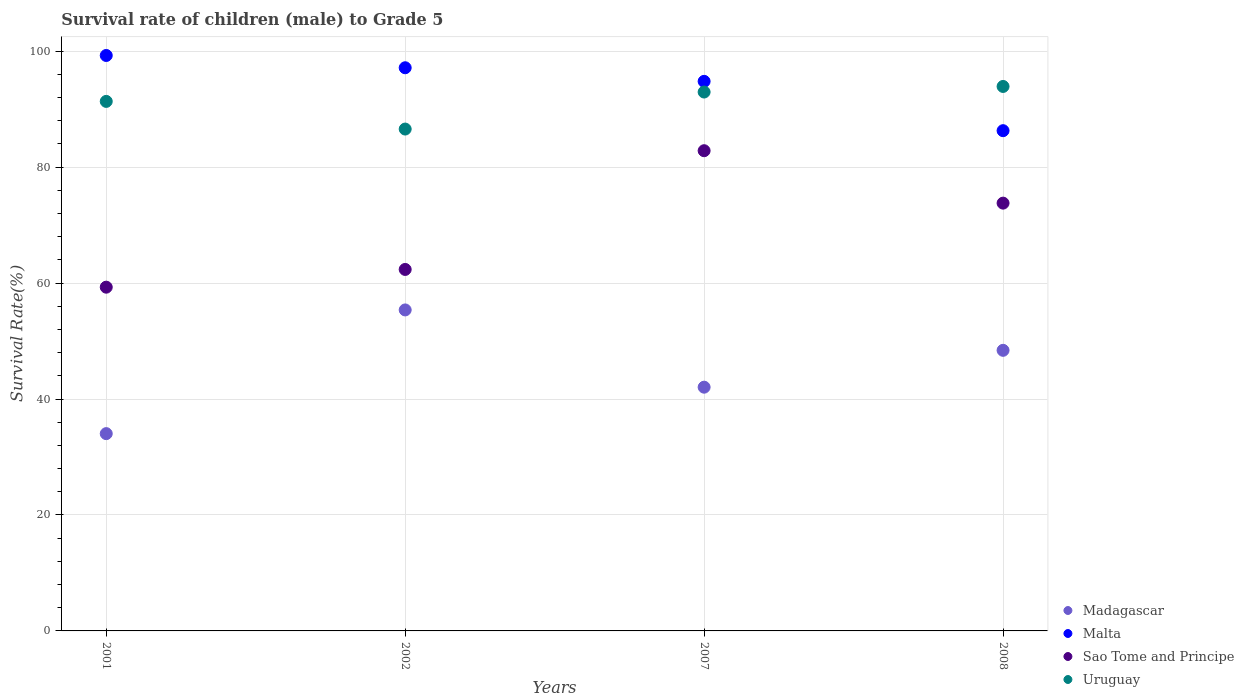Is the number of dotlines equal to the number of legend labels?
Your response must be concise. Yes. What is the survival rate of male children to grade 5 in Madagascar in 2008?
Make the answer very short. 48.4. Across all years, what is the maximum survival rate of male children to grade 5 in Madagascar?
Give a very brief answer. 55.37. Across all years, what is the minimum survival rate of male children to grade 5 in Malta?
Provide a short and direct response. 86.29. What is the total survival rate of male children to grade 5 in Sao Tome and Principe in the graph?
Provide a succinct answer. 278.27. What is the difference between the survival rate of male children to grade 5 in Uruguay in 2002 and that in 2008?
Make the answer very short. -7.35. What is the difference between the survival rate of male children to grade 5 in Uruguay in 2001 and the survival rate of male children to grade 5 in Malta in 2007?
Provide a succinct answer. -3.46. What is the average survival rate of male children to grade 5 in Madagascar per year?
Offer a terse response. 44.96. In the year 2008, what is the difference between the survival rate of male children to grade 5 in Sao Tome and Principe and survival rate of male children to grade 5 in Madagascar?
Make the answer very short. 25.39. What is the ratio of the survival rate of male children to grade 5 in Madagascar in 2002 to that in 2008?
Ensure brevity in your answer.  1.14. Is the survival rate of male children to grade 5 in Sao Tome and Principe in 2001 less than that in 2002?
Offer a very short reply. Yes. Is the difference between the survival rate of male children to grade 5 in Sao Tome and Principe in 2007 and 2008 greater than the difference between the survival rate of male children to grade 5 in Madagascar in 2007 and 2008?
Provide a succinct answer. Yes. What is the difference between the highest and the second highest survival rate of male children to grade 5 in Madagascar?
Ensure brevity in your answer.  6.97. What is the difference between the highest and the lowest survival rate of male children to grade 5 in Sao Tome and Principe?
Your answer should be very brief. 23.54. In how many years, is the survival rate of male children to grade 5 in Uruguay greater than the average survival rate of male children to grade 5 in Uruguay taken over all years?
Keep it short and to the point. 3. Is it the case that in every year, the sum of the survival rate of male children to grade 5 in Madagascar and survival rate of male children to grade 5 in Uruguay  is greater than the survival rate of male children to grade 5 in Sao Tome and Principe?
Keep it short and to the point. Yes. Does the survival rate of male children to grade 5 in Malta monotonically increase over the years?
Provide a short and direct response. No. How many dotlines are there?
Your answer should be very brief. 4. Does the graph contain grids?
Keep it short and to the point. Yes. What is the title of the graph?
Provide a succinct answer. Survival rate of children (male) to Grade 5. Does "OECD members" appear as one of the legend labels in the graph?
Make the answer very short. No. What is the label or title of the X-axis?
Offer a terse response. Years. What is the label or title of the Y-axis?
Ensure brevity in your answer.  Survival Rate(%). What is the Survival Rate(%) of Madagascar in 2001?
Provide a short and direct response. 34.03. What is the Survival Rate(%) in Malta in 2001?
Provide a short and direct response. 99.26. What is the Survival Rate(%) of Sao Tome and Principe in 2001?
Offer a terse response. 59.29. What is the Survival Rate(%) of Uruguay in 2001?
Make the answer very short. 91.34. What is the Survival Rate(%) of Madagascar in 2002?
Your answer should be very brief. 55.37. What is the Survival Rate(%) in Malta in 2002?
Your response must be concise. 97.14. What is the Survival Rate(%) in Sao Tome and Principe in 2002?
Keep it short and to the point. 62.35. What is the Survival Rate(%) in Uruguay in 2002?
Keep it short and to the point. 86.57. What is the Survival Rate(%) in Madagascar in 2007?
Keep it short and to the point. 42.04. What is the Survival Rate(%) of Malta in 2007?
Provide a short and direct response. 94.8. What is the Survival Rate(%) of Sao Tome and Principe in 2007?
Keep it short and to the point. 82.83. What is the Survival Rate(%) of Uruguay in 2007?
Your response must be concise. 92.95. What is the Survival Rate(%) of Madagascar in 2008?
Your response must be concise. 48.4. What is the Survival Rate(%) of Malta in 2008?
Offer a very short reply. 86.29. What is the Survival Rate(%) of Sao Tome and Principe in 2008?
Your answer should be very brief. 73.79. What is the Survival Rate(%) of Uruguay in 2008?
Your answer should be very brief. 93.92. Across all years, what is the maximum Survival Rate(%) of Madagascar?
Provide a short and direct response. 55.37. Across all years, what is the maximum Survival Rate(%) in Malta?
Keep it short and to the point. 99.26. Across all years, what is the maximum Survival Rate(%) in Sao Tome and Principe?
Your answer should be very brief. 82.83. Across all years, what is the maximum Survival Rate(%) of Uruguay?
Give a very brief answer. 93.92. Across all years, what is the minimum Survival Rate(%) of Madagascar?
Provide a short and direct response. 34.03. Across all years, what is the minimum Survival Rate(%) of Malta?
Your answer should be very brief. 86.29. Across all years, what is the minimum Survival Rate(%) of Sao Tome and Principe?
Provide a succinct answer. 59.29. Across all years, what is the minimum Survival Rate(%) in Uruguay?
Make the answer very short. 86.57. What is the total Survival Rate(%) in Madagascar in the graph?
Provide a succinct answer. 179.84. What is the total Survival Rate(%) in Malta in the graph?
Provide a succinct answer. 377.48. What is the total Survival Rate(%) of Sao Tome and Principe in the graph?
Make the answer very short. 278.27. What is the total Survival Rate(%) of Uruguay in the graph?
Offer a terse response. 364.77. What is the difference between the Survival Rate(%) of Madagascar in 2001 and that in 2002?
Offer a very short reply. -21.34. What is the difference between the Survival Rate(%) in Malta in 2001 and that in 2002?
Give a very brief answer. 2.12. What is the difference between the Survival Rate(%) of Sao Tome and Principe in 2001 and that in 2002?
Your response must be concise. -3.06. What is the difference between the Survival Rate(%) of Uruguay in 2001 and that in 2002?
Your answer should be compact. 4.77. What is the difference between the Survival Rate(%) in Madagascar in 2001 and that in 2007?
Your answer should be compact. -8.01. What is the difference between the Survival Rate(%) of Malta in 2001 and that in 2007?
Offer a very short reply. 4.46. What is the difference between the Survival Rate(%) of Sao Tome and Principe in 2001 and that in 2007?
Make the answer very short. -23.54. What is the difference between the Survival Rate(%) of Uruguay in 2001 and that in 2007?
Offer a terse response. -1.61. What is the difference between the Survival Rate(%) in Madagascar in 2001 and that in 2008?
Offer a terse response. -14.37. What is the difference between the Survival Rate(%) in Malta in 2001 and that in 2008?
Your response must be concise. 12.97. What is the difference between the Survival Rate(%) of Sao Tome and Principe in 2001 and that in 2008?
Give a very brief answer. -14.5. What is the difference between the Survival Rate(%) in Uruguay in 2001 and that in 2008?
Make the answer very short. -2.58. What is the difference between the Survival Rate(%) in Madagascar in 2002 and that in 2007?
Make the answer very short. 13.32. What is the difference between the Survival Rate(%) of Malta in 2002 and that in 2007?
Provide a succinct answer. 2.35. What is the difference between the Survival Rate(%) of Sao Tome and Principe in 2002 and that in 2007?
Offer a very short reply. -20.48. What is the difference between the Survival Rate(%) in Uruguay in 2002 and that in 2007?
Offer a terse response. -6.39. What is the difference between the Survival Rate(%) of Madagascar in 2002 and that in 2008?
Ensure brevity in your answer.  6.97. What is the difference between the Survival Rate(%) of Malta in 2002 and that in 2008?
Offer a terse response. 10.85. What is the difference between the Survival Rate(%) in Sao Tome and Principe in 2002 and that in 2008?
Provide a succinct answer. -11.44. What is the difference between the Survival Rate(%) of Uruguay in 2002 and that in 2008?
Give a very brief answer. -7.35. What is the difference between the Survival Rate(%) of Madagascar in 2007 and that in 2008?
Your response must be concise. -6.36. What is the difference between the Survival Rate(%) of Malta in 2007 and that in 2008?
Give a very brief answer. 8.51. What is the difference between the Survival Rate(%) of Sao Tome and Principe in 2007 and that in 2008?
Make the answer very short. 9.04. What is the difference between the Survival Rate(%) of Uruguay in 2007 and that in 2008?
Provide a succinct answer. -0.96. What is the difference between the Survival Rate(%) in Madagascar in 2001 and the Survival Rate(%) in Malta in 2002?
Make the answer very short. -63.11. What is the difference between the Survival Rate(%) of Madagascar in 2001 and the Survival Rate(%) of Sao Tome and Principe in 2002?
Keep it short and to the point. -28.32. What is the difference between the Survival Rate(%) in Madagascar in 2001 and the Survival Rate(%) in Uruguay in 2002?
Offer a terse response. -52.54. What is the difference between the Survival Rate(%) in Malta in 2001 and the Survival Rate(%) in Sao Tome and Principe in 2002?
Provide a short and direct response. 36.91. What is the difference between the Survival Rate(%) in Malta in 2001 and the Survival Rate(%) in Uruguay in 2002?
Provide a succinct answer. 12.69. What is the difference between the Survival Rate(%) in Sao Tome and Principe in 2001 and the Survival Rate(%) in Uruguay in 2002?
Make the answer very short. -27.27. What is the difference between the Survival Rate(%) in Madagascar in 2001 and the Survival Rate(%) in Malta in 2007?
Provide a short and direct response. -60.77. What is the difference between the Survival Rate(%) in Madagascar in 2001 and the Survival Rate(%) in Sao Tome and Principe in 2007?
Ensure brevity in your answer.  -48.8. What is the difference between the Survival Rate(%) in Madagascar in 2001 and the Survival Rate(%) in Uruguay in 2007?
Make the answer very short. -58.92. What is the difference between the Survival Rate(%) in Malta in 2001 and the Survival Rate(%) in Sao Tome and Principe in 2007?
Make the answer very short. 16.43. What is the difference between the Survival Rate(%) of Malta in 2001 and the Survival Rate(%) of Uruguay in 2007?
Make the answer very short. 6.31. What is the difference between the Survival Rate(%) in Sao Tome and Principe in 2001 and the Survival Rate(%) in Uruguay in 2007?
Your response must be concise. -33.66. What is the difference between the Survival Rate(%) of Madagascar in 2001 and the Survival Rate(%) of Malta in 2008?
Keep it short and to the point. -52.26. What is the difference between the Survival Rate(%) of Madagascar in 2001 and the Survival Rate(%) of Sao Tome and Principe in 2008?
Your answer should be very brief. -39.76. What is the difference between the Survival Rate(%) in Madagascar in 2001 and the Survival Rate(%) in Uruguay in 2008?
Keep it short and to the point. -59.88. What is the difference between the Survival Rate(%) in Malta in 2001 and the Survival Rate(%) in Sao Tome and Principe in 2008?
Provide a succinct answer. 25.47. What is the difference between the Survival Rate(%) of Malta in 2001 and the Survival Rate(%) of Uruguay in 2008?
Your response must be concise. 5.34. What is the difference between the Survival Rate(%) in Sao Tome and Principe in 2001 and the Survival Rate(%) in Uruguay in 2008?
Your response must be concise. -34.62. What is the difference between the Survival Rate(%) in Madagascar in 2002 and the Survival Rate(%) in Malta in 2007?
Give a very brief answer. -39.43. What is the difference between the Survival Rate(%) of Madagascar in 2002 and the Survival Rate(%) of Sao Tome and Principe in 2007?
Your answer should be compact. -27.46. What is the difference between the Survival Rate(%) of Madagascar in 2002 and the Survival Rate(%) of Uruguay in 2007?
Your answer should be compact. -37.59. What is the difference between the Survival Rate(%) in Malta in 2002 and the Survival Rate(%) in Sao Tome and Principe in 2007?
Provide a succinct answer. 14.31. What is the difference between the Survival Rate(%) of Malta in 2002 and the Survival Rate(%) of Uruguay in 2007?
Your response must be concise. 4.19. What is the difference between the Survival Rate(%) in Sao Tome and Principe in 2002 and the Survival Rate(%) in Uruguay in 2007?
Your answer should be compact. -30.6. What is the difference between the Survival Rate(%) of Madagascar in 2002 and the Survival Rate(%) of Malta in 2008?
Your response must be concise. -30.92. What is the difference between the Survival Rate(%) of Madagascar in 2002 and the Survival Rate(%) of Sao Tome and Principe in 2008?
Offer a terse response. -18.42. What is the difference between the Survival Rate(%) of Madagascar in 2002 and the Survival Rate(%) of Uruguay in 2008?
Offer a very short reply. -38.55. What is the difference between the Survival Rate(%) in Malta in 2002 and the Survival Rate(%) in Sao Tome and Principe in 2008?
Ensure brevity in your answer.  23.35. What is the difference between the Survival Rate(%) in Malta in 2002 and the Survival Rate(%) in Uruguay in 2008?
Your answer should be very brief. 3.23. What is the difference between the Survival Rate(%) in Sao Tome and Principe in 2002 and the Survival Rate(%) in Uruguay in 2008?
Offer a terse response. -31.56. What is the difference between the Survival Rate(%) of Madagascar in 2007 and the Survival Rate(%) of Malta in 2008?
Give a very brief answer. -44.24. What is the difference between the Survival Rate(%) in Madagascar in 2007 and the Survival Rate(%) in Sao Tome and Principe in 2008?
Make the answer very short. -31.75. What is the difference between the Survival Rate(%) in Madagascar in 2007 and the Survival Rate(%) in Uruguay in 2008?
Offer a very short reply. -51.87. What is the difference between the Survival Rate(%) in Malta in 2007 and the Survival Rate(%) in Sao Tome and Principe in 2008?
Offer a very short reply. 21.01. What is the difference between the Survival Rate(%) in Malta in 2007 and the Survival Rate(%) in Uruguay in 2008?
Your answer should be very brief. 0.88. What is the difference between the Survival Rate(%) in Sao Tome and Principe in 2007 and the Survival Rate(%) in Uruguay in 2008?
Provide a short and direct response. -11.08. What is the average Survival Rate(%) in Madagascar per year?
Your response must be concise. 44.96. What is the average Survival Rate(%) of Malta per year?
Your response must be concise. 94.37. What is the average Survival Rate(%) in Sao Tome and Principe per year?
Offer a terse response. 69.57. What is the average Survival Rate(%) in Uruguay per year?
Make the answer very short. 91.19. In the year 2001, what is the difference between the Survival Rate(%) in Madagascar and Survival Rate(%) in Malta?
Ensure brevity in your answer.  -65.23. In the year 2001, what is the difference between the Survival Rate(%) in Madagascar and Survival Rate(%) in Sao Tome and Principe?
Your answer should be very brief. -25.26. In the year 2001, what is the difference between the Survival Rate(%) in Madagascar and Survival Rate(%) in Uruguay?
Provide a succinct answer. -57.31. In the year 2001, what is the difference between the Survival Rate(%) in Malta and Survival Rate(%) in Sao Tome and Principe?
Your answer should be compact. 39.97. In the year 2001, what is the difference between the Survival Rate(%) of Malta and Survival Rate(%) of Uruguay?
Your answer should be compact. 7.92. In the year 2001, what is the difference between the Survival Rate(%) of Sao Tome and Principe and Survival Rate(%) of Uruguay?
Offer a very short reply. -32.05. In the year 2002, what is the difference between the Survival Rate(%) of Madagascar and Survival Rate(%) of Malta?
Offer a very short reply. -41.77. In the year 2002, what is the difference between the Survival Rate(%) of Madagascar and Survival Rate(%) of Sao Tome and Principe?
Provide a short and direct response. -6.98. In the year 2002, what is the difference between the Survival Rate(%) in Madagascar and Survival Rate(%) in Uruguay?
Keep it short and to the point. -31.2. In the year 2002, what is the difference between the Survival Rate(%) of Malta and Survival Rate(%) of Sao Tome and Principe?
Your response must be concise. 34.79. In the year 2002, what is the difference between the Survival Rate(%) of Malta and Survival Rate(%) of Uruguay?
Your response must be concise. 10.58. In the year 2002, what is the difference between the Survival Rate(%) of Sao Tome and Principe and Survival Rate(%) of Uruguay?
Give a very brief answer. -24.21. In the year 2007, what is the difference between the Survival Rate(%) of Madagascar and Survival Rate(%) of Malta?
Offer a very short reply. -52.75. In the year 2007, what is the difference between the Survival Rate(%) of Madagascar and Survival Rate(%) of Sao Tome and Principe?
Ensure brevity in your answer.  -40.79. In the year 2007, what is the difference between the Survival Rate(%) in Madagascar and Survival Rate(%) in Uruguay?
Provide a short and direct response. -50.91. In the year 2007, what is the difference between the Survival Rate(%) in Malta and Survival Rate(%) in Sao Tome and Principe?
Your answer should be very brief. 11.96. In the year 2007, what is the difference between the Survival Rate(%) in Malta and Survival Rate(%) in Uruguay?
Keep it short and to the point. 1.84. In the year 2007, what is the difference between the Survival Rate(%) in Sao Tome and Principe and Survival Rate(%) in Uruguay?
Ensure brevity in your answer.  -10.12. In the year 2008, what is the difference between the Survival Rate(%) of Madagascar and Survival Rate(%) of Malta?
Offer a very short reply. -37.89. In the year 2008, what is the difference between the Survival Rate(%) in Madagascar and Survival Rate(%) in Sao Tome and Principe?
Keep it short and to the point. -25.39. In the year 2008, what is the difference between the Survival Rate(%) in Madagascar and Survival Rate(%) in Uruguay?
Keep it short and to the point. -45.52. In the year 2008, what is the difference between the Survival Rate(%) in Malta and Survival Rate(%) in Sao Tome and Principe?
Make the answer very short. 12.5. In the year 2008, what is the difference between the Survival Rate(%) of Malta and Survival Rate(%) of Uruguay?
Your answer should be very brief. -7.63. In the year 2008, what is the difference between the Survival Rate(%) of Sao Tome and Principe and Survival Rate(%) of Uruguay?
Offer a very short reply. -20.13. What is the ratio of the Survival Rate(%) of Madagascar in 2001 to that in 2002?
Offer a terse response. 0.61. What is the ratio of the Survival Rate(%) of Malta in 2001 to that in 2002?
Your response must be concise. 1.02. What is the ratio of the Survival Rate(%) of Sao Tome and Principe in 2001 to that in 2002?
Offer a terse response. 0.95. What is the ratio of the Survival Rate(%) of Uruguay in 2001 to that in 2002?
Keep it short and to the point. 1.06. What is the ratio of the Survival Rate(%) of Madagascar in 2001 to that in 2007?
Make the answer very short. 0.81. What is the ratio of the Survival Rate(%) in Malta in 2001 to that in 2007?
Keep it short and to the point. 1.05. What is the ratio of the Survival Rate(%) in Sao Tome and Principe in 2001 to that in 2007?
Keep it short and to the point. 0.72. What is the ratio of the Survival Rate(%) of Uruguay in 2001 to that in 2007?
Make the answer very short. 0.98. What is the ratio of the Survival Rate(%) of Madagascar in 2001 to that in 2008?
Offer a terse response. 0.7. What is the ratio of the Survival Rate(%) of Malta in 2001 to that in 2008?
Give a very brief answer. 1.15. What is the ratio of the Survival Rate(%) in Sao Tome and Principe in 2001 to that in 2008?
Your answer should be compact. 0.8. What is the ratio of the Survival Rate(%) of Uruguay in 2001 to that in 2008?
Offer a very short reply. 0.97. What is the ratio of the Survival Rate(%) of Madagascar in 2002 to that in 2007?
Ensure brevity in your answer.  1.32. What is the ratio of the Survival Rate(%) in Malta in 2002 to that in 2007?
Provide a succinct answer. 1.02. What is the ratio of the Survival Rate(%) in Sao Tome and Principe in 2002 to that in 2007?
Provide a succinct answer. 0.75. What is the ratio of the Survival Rate(%) in Uruguay in 2002 to that in 2007?
Give a very brief answer. 0.93. What is the ratio of the Survival Rate(%) of Madagascar in 2002 to that in 2008?
Provide a short and direct response. 1.14. What is the ratio of the Survival Rate(%) in Malta in 2002 to that in 2008?
Ensure brevity in your answer.  1.13. What is the ratio of the Survival Rate(%) of Sao Tome and Principe in 2002 to that in 2008?
Keep it short and to the point. 0.84. What is the ratio of the Survival Rate(%) in Uruguay in 2002 to that in 2008?
Offer a terse response. 0.92. What is the ratio of the Survival Rate(%) in Madagascar in 2007 to that in 2008?
Your answer should be very brief. 0.87. What is the ratio of the Survival Rate(%) of Malta in 2007 to that in 2008?
Offer a very short reply. 1.1. What is the ratio of the Survival Rate(%) of Sao Tome and Principe in 2007 to that in 2008?
Keep it short and to the point. 1.12. What is the ratio of the Survival Rate(%) in Uruguay in 2007 to that in 2008?
Provide a succinct answer. 0.99. What is the difference between the highest and the second highest Survival Rate(%) of Madagascar?
Your response must be concise. 6.97. What is the difference between the highest and the second highest Survival Rate(%) in Malta?
Provide a short and direct response. 2.12. What is the difference between the highest and the second highest Survival Rate(%) in Sao Tome and Principe?
Your answer should be compact. 9.04. What is the difference between the highest and the second highest Survival Rate(%) of Uruguay?
Your answer should be compact. 0.96. What is the difference between the highest and the lowest Survival Rate(%) in Madagascar?
Offer a very short reply. 21.34. What is the difference between the highest and the lowest Survival Rate(%) in Malta?
Offer a very short reply. 12.97. What is the difference between the highest and the lowest Survival Rate(%) in Sao Tome and Principe?
Make the answer very short. 23.54. What is the difference between the highest and the lowest Survival Rate(%) in Uruguay?
Keep it short and to the point. 7.35. 